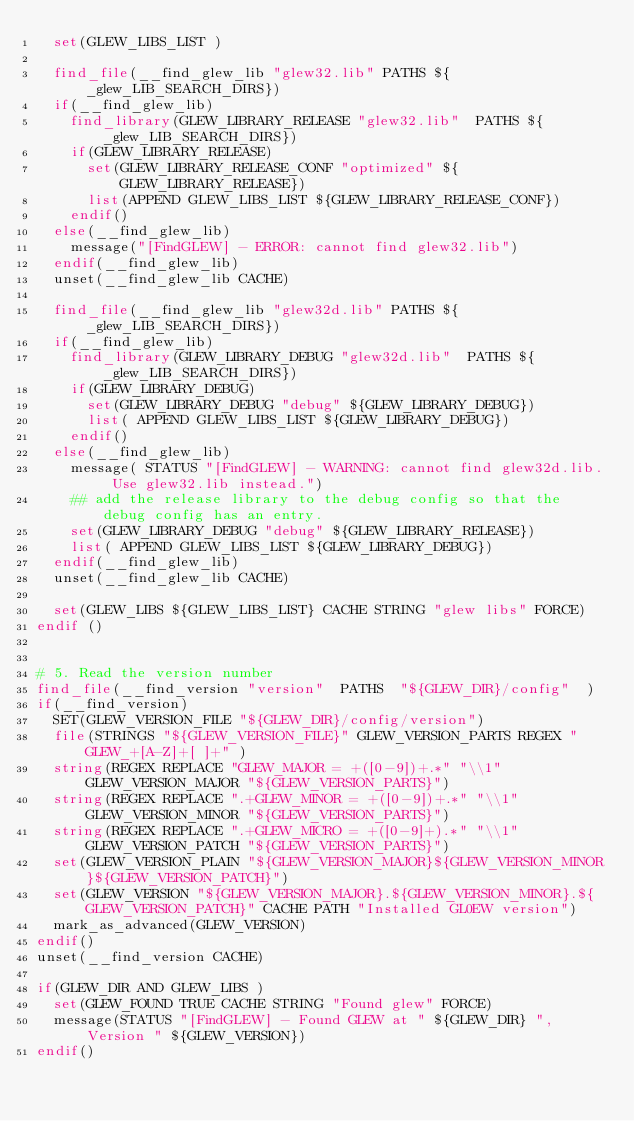<code> <loc_0><loc_0><loc_500><loc_500><_CMake_>	set(GLEW_LIBS_LIST )

	find_file(__find_glew_lib "glew32.lib" PATHS ${_glew_LIB_SEARCH_DIRS})
	if(__find_glew_lib)
		find_library(GLEW_LIBRARY_RELEASE "glew32.lib"  PATHS ${_glew_LIB_SEARCH_DIRS})
		if(GLEW_LIBRARY_RELEASE)
			set(GLEW_LIBRARY_RELEASE_CONF "optimized" ${GLEW_LIBRARY_RELEASE})
			list(APPEND GLEW_LIBS_LIST ${GLEW_LIBRARY_RELEASE_CONF})
		endif()
	else(__find_glew_lib)
		message("[FindGLEW] - ERROR: cannot find glew32.lib")
	endif(__find_glew_lib)
	unset(__find_glew_lib CACHE)

	find_file(__find_glew_lib "glew32d.lib" PATHS ${_glew_LIB_SEARCH_DIRS})
	if(__find_glew_lib)
		find_library(GLEW_LIBRARY_DEBUG "glew32d.lib"  PATHS ${_glew_LIB_SEARCH_DIRS})
		if(GLEW_LIBRARY_DEBUG)
			set(GLEW_LIBRARY_DEBUG "debug" ${GLEW_LIBRARY_DEBUG})
			list( APPEND GLEW_LIBS_LIST ${GLEW_LIBRARY_DEBUG})
		endif()
	else(__find_glew_lib)
		message( STATUS "[FindGLEW] - WARNING: cannot find glew32d.lib. Use glew32.lib instead.")
		## add the release library to the debug config so that the debug config has an entry. 
		set(GLEW_LIBRARY_DEBUG "debug" ${GLEW_LIBRARY_RELEASE})
		list( APPEND GLEW_LIBS_LIST ${GLEW_LIBRARY_DEBUG})
	endif(__find_glew_lib)
	unset(__find_glew_lib CACHE)
	
	set(GLEW_LIBS ${GLEW_LIBS_LIST} CACHE STRING "glew libs" FORCE)
endif ()


# 5. Read the version number
find_file(__find_version "version"  PATHS  "${GLEW_DIR}/config"  )
if(__find_version)
	SET(GLEW_VERSION_FILE "${GLEW_DIR}/config/version")
	file(STRINGS "${GLEW_VERSION_FILE}" GLEW_VERSION_PARTS REGEX "GLEW_+[A-Z]+[ ]+" )
	string(REGEX REPLACE "GLEW_MAJOR = +([0-9])+.*" "\\1" GLEW_VERSION_MAJOR "${GLEW_VERSION_PARTS}")
	string(REGEX REPLACE ".+GLEW_MINOR = +([0-9])+.*" "\\1" GLEW_VERSION_MINOR "${GLEW_VERSION_PARTS}")
	string(REGEX REPLACE ".+GLEW_MICRO = +([0-9]+).*" "\\1" GLEW_VERSION_PATCH "${GLEW_VERSION_PARTS}")
	set(GLEW_VERSION_PLAIN "${GLEW_VERSION_MAJOR}${GLEW_VERSION_MINOR}${GLEW_VERSION_PATCH}")
	set(GLEW_VERSION "${GLEW_VERSION_MAJOR}.${GLEW_VERSION_MINOR}.${GLEW_VERSION_PATCH}" CACHE PATH "Installed GL0EW version")
	mark_as_advanced(GLEW_VERSION)
endif()
unset(__find_version CACHE)

if(GLEW_DIR AND GLEW_LIBS ) 
	set(GLEW_FOUND TRUE CACHE STRING "Found glew" FORCE)
	message(STATUS "[FindGLEW] - Found GLEW at " ${GLEW_DIR} ", Version " ${GLEW_VERSION})
endif()


</code> 